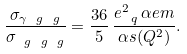Convert formula to latex. <formula><loc_0><loc_0><loc_500><loc_500>\frac { \sigma _ { \gamma \ g \ g } } { \sigma _ { \ g \ g \ g } } = \frac { 3 6 } { 5 } \, \frac { e _ { \ q } ^ { 2 } \, \alpha e m } { \alpha s ( Q ^ { 2 } ) } .</formula> 